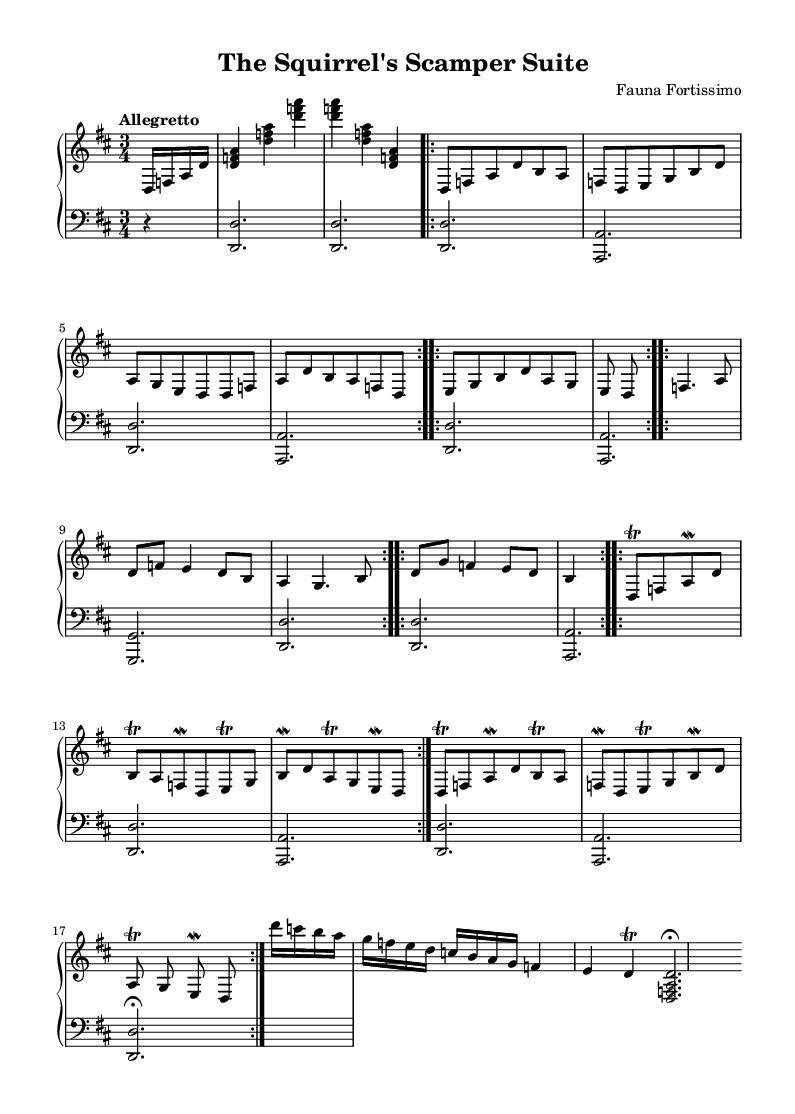What is the key signature of this music? The key signature is indicated at the beginning of the piece. There are two sharps shown, which correspond to F# and C#. This means the key signature is D major.
Answer: D major What is the time signature of this music? The time signature is located at the beginning of the staffs where it shows the beat division. It states 3 over 4, meaning there are three beats in a measure, and each beat is a quarter note.
Answer: 3/4 What is the tempo marking of this music? The tempo marking is found at the beginning of the score, where it specifies how quickly the piece should be played. Here, it states "Allegretto," which means a moderately fast pace.
Answer: Allegretto How many times is Theme A repeated? To find this, we look for the repeat signs and notations concerning Theme A. It is marked to be repeated twice, as indicated by the repeat volta notation.
Answer: 2 What is the first note of the Coda section? The Coda section starts with a measure that lists the notes sequentially. Observing the Coda indicates that the first note played is D, classified by the note placements on the staff.
Answer: D What type of ornamentation is used in the Theme A Variation? In Theme A Variation, the notes include trills and mordents, which are symbols shown next to specific notes indicating the use of ornamentation. This ornamentation includes quick alternations of the specified note with the next higher note.
Answer: Trill and mordent What is the instrumentation for this piece? The instrumentation can be discerned from the sections labeled at the start of the score. The work is written for a PianoStaff, indicating it is intended for a solo harpsichord.
Answer: Harpsichord 